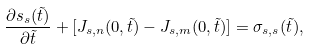Convert formula to latex. <formula><loc_0><loc_0><loc_500><loc_500>\frac { \partial s _ { s } ( \tilde { t } ) } { \partial \tilde { t } } + [ J _ { s , n } ( 0 , \tilde { t } ) - J _ { s , m } ( 0 , \tilde { t } ) ] = \sigma _ { s , s } ( \tilde { t } ) ,</formula> 